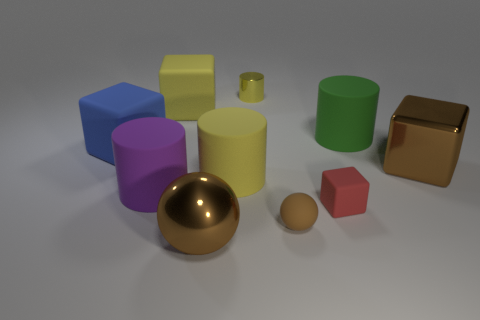There is a small cube that is made of the same material as the big purple thing; what is its color?
Your response must be concise. Red. Is the shape of the yellow matte object that is right of the large brown ball the same as  the large green thing?
Your answer should be compact. Yes. What number of objects are either tiny objects that are behind the large yellow cube or small objects that are behind the big yellow cube?
Your answer should be very brief. 1. The metallic object that is the same shape as the big blue rubber thing is what color?
Your answer should be compact. Brown. There is a big blue object; does it have the same shape as the big brown thing behind the purple matte cylinder?
Give a very brief answer. Yes. What material is the big brown block?
Offer a very short reply. Metal. What is the size of the metallic object that is the same shape as the big green rubber thing?
Provide a succinct answer. Small. What number of other objects are the same material as the tiny yellow cylinder?
Make the answer very short. 2. Does the big green cylinder have the same material as the ball on the left side of the shiny cylinder?
Offer a terse response. No. Is the number of tiny yellow cylinders that are right of the tiny red cube less than the number of big matte things that are to the left of the tiny yellow object?
Keep it short and to the point. Yes. 